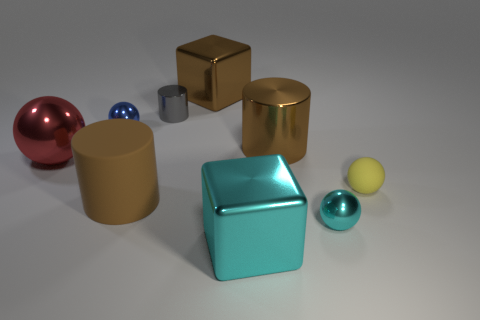The big shiny ball has what color?
Your response must be concise. Red. Are there any balls behind the tiny cyan metal object?
Make the answer very short. Yes. Do the big rubber thing and the large metallic cylinder have the same color?
Give a very brief answer. Yes. How many metal spheres are the same color as the small matte object?
Make the answer very short. 0. There is a sphere that is to the right of the tiny metallic sphere in front of the tiny yellow matte ball; what size is it?
Your answer should be compact. Small. What is the shape of the blue metallic object?
Offer a very short reply. Sphere. What material is the tiny yellow thing behind the large brown matte cylinder?
Ensure brevity in your answer.  Rubber. What color is the matte object right of the large object in front of the large brown object that is in front of the small yellow rubber thing?
Offer a terse response. Yellow. What is the color of the other matte ball that is the same size as the cyan ball?
Your answer should be very brief. Yellow. How many metal things are cyan objects or tiny yellow balls?
Your answer should be compact. 2. 